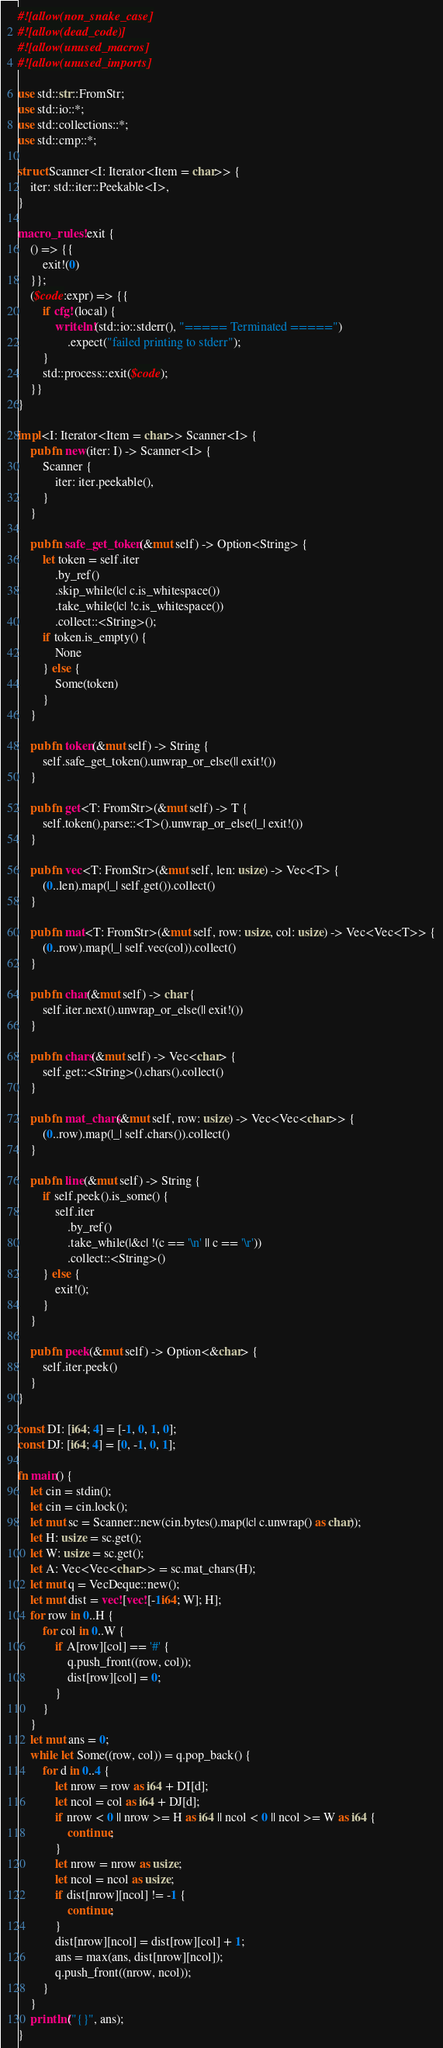Convert code to text. <code><loc_0><loc_0><loc_500><loc_500><_Rust_>#![allow(non_snake_case)]
#![allow(dead_code)]
#![allow(unused_macros)]
#![allow(unused_imports)]

use std::str::FromStr;
use std::io::*;
use std::collections::*;
use std::cmp::*;

struct Scanner<I: Iterator<Item = char>> {
    iter: std::iter::Peekable<I>,
}

macro_rules! exit {
    () => {{
        exit!(0)
    }};
    ($code:expr) => {{
        if cfg!(local) {
            writeln!(std::io::stderr(), "===== Terminated =====")
                .expect("failed printing to stderr");
        }
        std::process::exit($code);
    }}
}

impl<I: Iterator<Item = char>> Scanner<I> {
    pub fn new(iter: I) -> Scanner<I> {
        Scanner {
            iter: iter.peekable(),
        }
    }

    pub fn safe_get_token(&mut self) -> Option<String> {
        let token = self.iter
            .by_ref()
            .skip_while(|c| c.is_whitespace())
            .take_while(|c| !c.is_whitespace())
            .collect::<String>();
        if token.is_empty() {
            None
        } else {
            Some(token)
        }
    }

    pub fn token(&mut self) -> String {
        self.safe_get_token().unwrap_or_else(|| exit!())
    }

    pub fn get<T: FromStr>(&mut self) -> T {
        self.token().parse::<T>().unwrap_or_else(|_| exit!())
    }

    pub fn vec<T: FromStr>(&mut self, len: usize) -> Vec<T> {
        (0..len).map(|_| self.get()).collect()
    }

    pub fn mat<T: FromStr>(&mut self, row: usize, col: usize) -> Vec<Vec<T>> {
        (0..row).map(|_| self.vec(col)).collect()
    }

    pub fn char(&mut self) -> char {
        self.iter.next().unwrap_or_else(|| exit!())
    }

    pub fn chars(&mut self) -> Vec<char> {
        self.get::<String>().chars().collect()
    }

    pub fn mat_chars(&mut self, row: usize) -> Vec<Vec<char>> {
        (0..row).map(|_| self.chars()).collect()
    }

    pub fn line(&mut self) -> String {
        if self.peek().is_some() {
            self.iter
                .by_ref()
                .take_while(|&c| !(c == '\n' || c == '\r'))
                .collect::<String>()
        } else {
            exit!();
        }
    }

    pub fn peek(&mut self) -> Option<&char> {
        self.iter.peek()
    }
}

const DI: [i64; 4] = [-1, 0, 1, 0];
const DJ: [i64; 4] = [0, -1, 0, 1];

fn main() {
    let cin = stdin();
    let cin = cin.lock();
    let mut sc = Scanner::new(cin.bytes().map(|c| c.unwrap() as char));
    let H: usize = sc.get();
    let W: usize = sc.get();
    let A: Vec<Vec<char>> = sc.mat_chars(H);
    let mut q = VecDeque::new();
    let mut dist = vec![vec![-1i64; W]; H];
    for row in 0..H {
        for col in 0..W {
            if A[row][col] == '#' {
                q.push_front((row, col));
                dist[row][col] = 0;
            }
        }
    }
    let mut ans = 0;
    while let Some((row, col)) = q.pop_back() {
        for d in 0..4 {
            let nrow = row as i64 + DI[d];
            let ncol = col as i64 + DJ[d];
            if nrow < 0 || nrow >= H as i64 || ncol < 0 || ncol >= W as i64 {
                continue;
            }
            let nrow = nrow as usize;
            let ncol = ncol as usize;
            if dist[nrow][ncol] != -1 {
                continue;
            }
            dist[nrow][ncol] = dist[row][col] + 1;
            ans = max(ans, dist[nrow][ncol]);
            q.push_front((nrow, ncol));
        }
    }
    println!("{}", ans);
}
</code> 